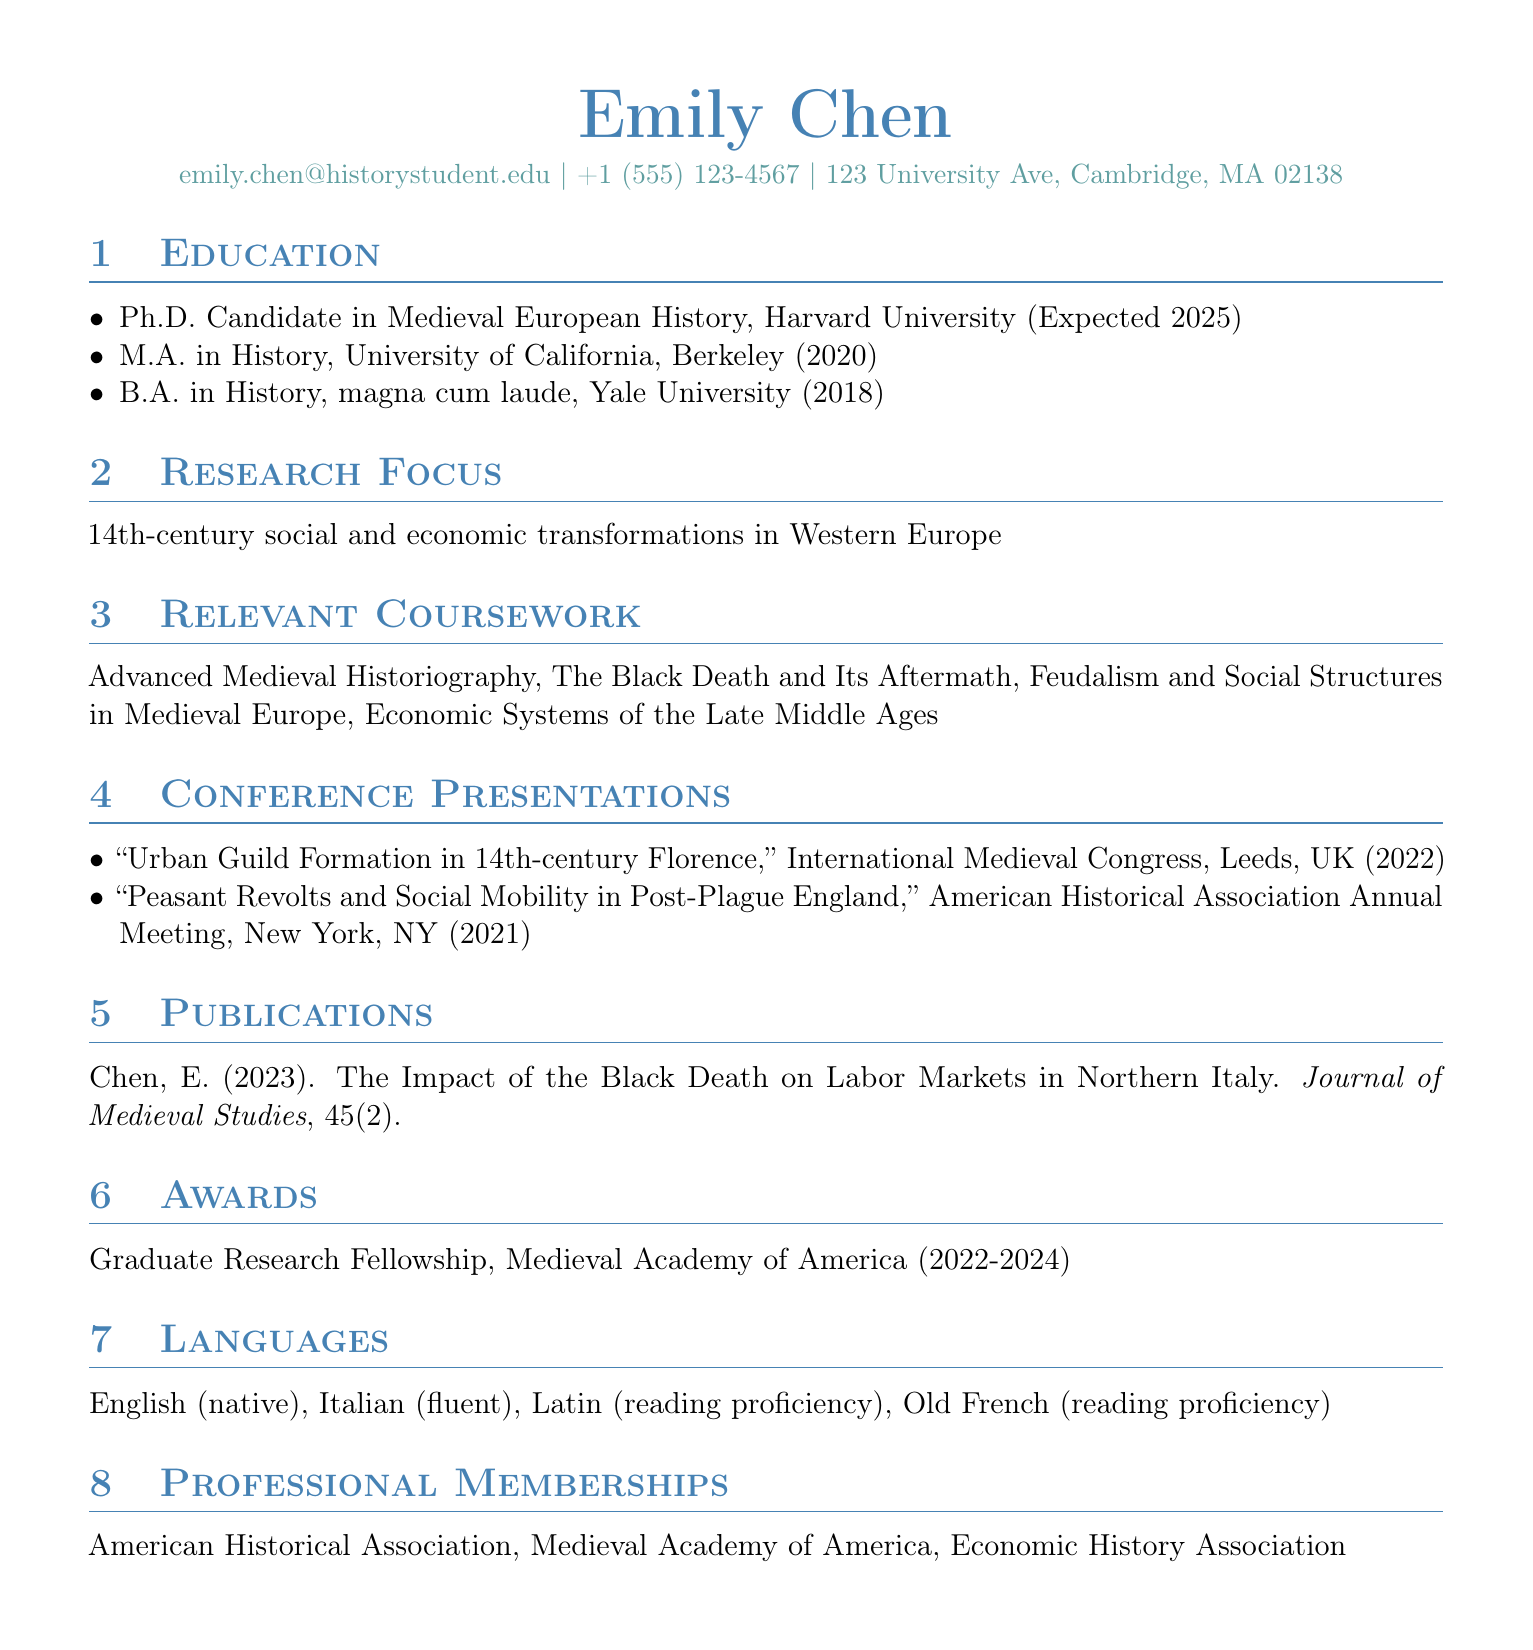What is the name of the candidate? The name of the candidate is listed in the personal information section.
Answer: Emily Chen What is the expected year of graduation for the Ph.D. program? The expected graduation year is mentioned in the education section for the Ph.D. program.
Answer: 2025 What is Emily Chen's research focus? The research focus is provided in a dedicated section of the CV.
Answer: 14th-century social and economic transformations in Western Europe How many languages can Emily Chen read with proficiency? The languages section enumerates the languages and their proficiency levels.
Answer: 2 What was the title of the presentation given at the International Medieval Congress? The title of the presentation at that conference is stated in the conference presentations section.
Answer: Urban Guild Formation in 14th-century Florence In which year was the publication in the Journal of Medieval Studies released? The publication year is specified in the publications section.
Answer: 2023 What award is Emily Chen currently holding? The awards section indicates the name of the award and the organization.
Answer: Graduate Research Fellowship Which institution awarded Emily Chen her M.A. degree? The M.A. degree institution is mentioned in the education section of the CV.
Answer: University of California, Berkeley What is the name of one professional membership organization? The professional memberships section lists various organizations Emily Chen is a member of.
Answer: American Historical Association 